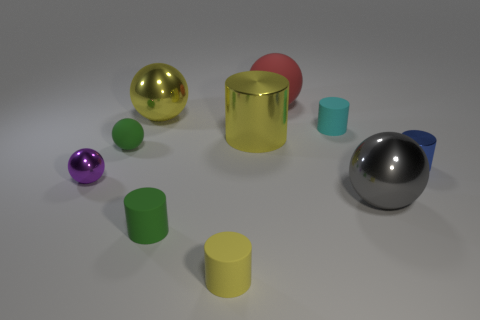What number of other objects are there of the same shape as the cyan matte thing?
Ensure brevity in your answer.  4. The rubber sphere on the left side of the green matte cylinder is what color?
Provide a succinct answer. Green. Is the color of the small ball on the right side of the tiny purple metal object the same as the large metallic cylinder?
Offer a very short reply. No. There is a cyan thing that is the same shape as the blue object; what is its size?
Your answer should be very brief. Small. Is there anything else that is the same size as the blue cylinder?
Provide a succinct answer. Yes. What material is the large sphere to the left of the matte sphere that is behind the green object behind the small purple ball?
Your response must be concise. Metal. Are there more rubber spheres to the left of the small yellow object than green balls that are on the right side of the gray object?
Keep it short and to the point. Yes. Is the size of the gray metal sphere the same as the red sphere?
Offer a terse response. Yes. There is another large thing that is the same shape as the cyan rubber object; what color is it?
Ensure brevity in your answer.  Yellow. What number of cylinders have the same color as the small rubber sphere?
Keep it short and to the point. 1. 